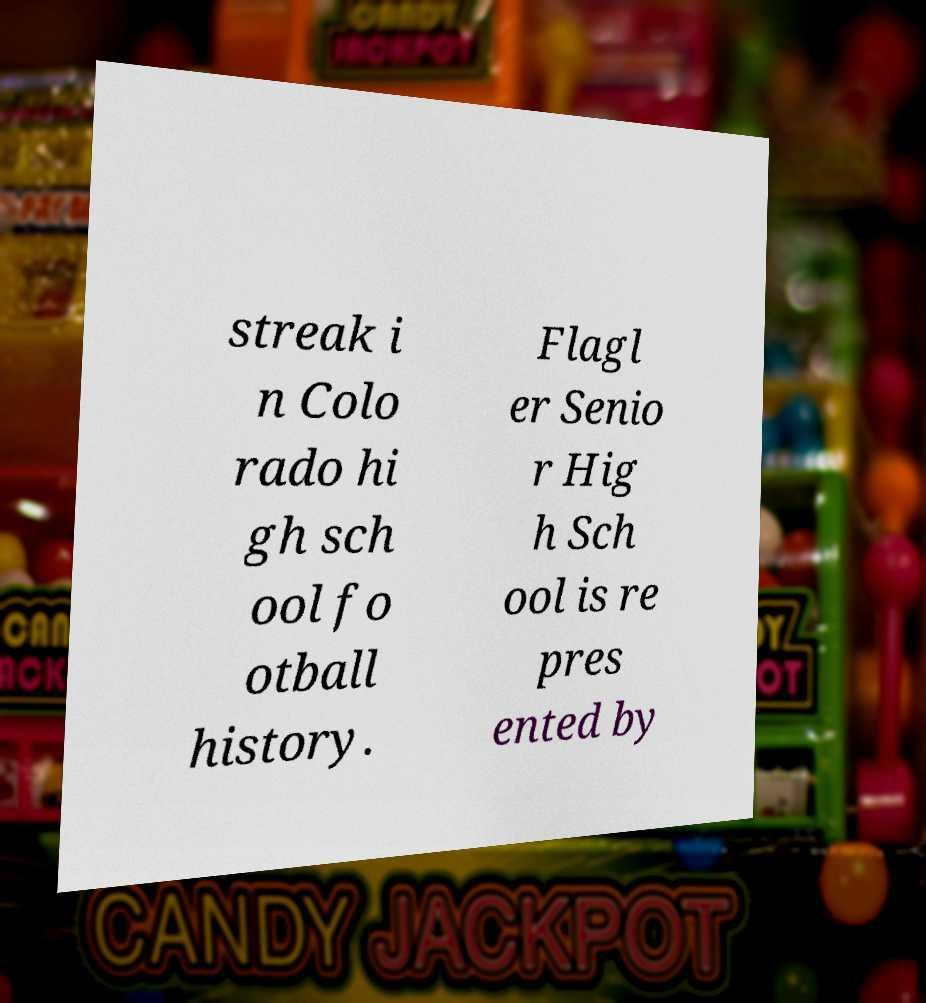Please read and relay the text visible in this image. What does it say? streak i n Colo rado hi gh sch ool fo otball history. Flagl er Senio r Hig h Sch ool is re pres ented by 